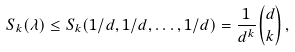Convert formula to latex. <formula><loc_0><loc_0><loc_500><loc_500>S _ { k } ( \lambda ) \leq S _ { k } ( 1 / d , 1 / d , \dots , 1 / d ) = \frac { 1 } { d ^ { k } } { d \choose k } \, ,</formula> 